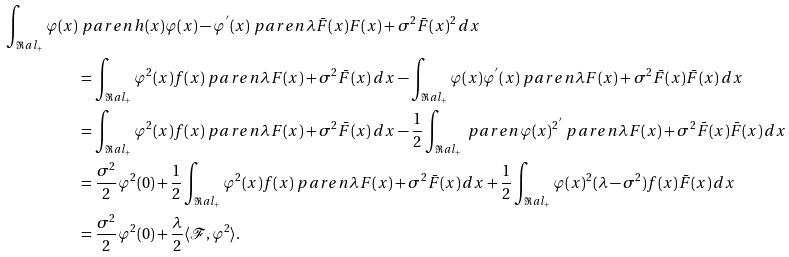<formula> <loc_0><loc_0><loc_500><loc_500>\int _ { \Re a l _ { + } } \varphi ( x ) & \ p a r e n { h ( x ) \varphi ( x ) - \varphi ^ { ^ { \prime } } ( x ) } \ p a r e n { \lambda \bar { F } ( x ) F ( x ) + \sigma ^ { 2 } \bar { F } ( x ) ^ { 2 } } \, d x \\ & = \int _ { \Re a l _ { + } } \varphi ^ { 2 } ( x ) f ( x ) \ p a r e n { \lambda F ( x ) + \sigma ^ { 2 } \bar { F } ( x ) } \, d x - \int _ { \Re a l _ { + } } \varphi ( x ) \varphi ^ { ^ { \prime } } ( x ) \ p a r e n { \lambda F ( x ) + \sigma ^ { 2 } \bar { F } ( x ) } \bar { F } ( x ) \, d x \\ & = \int _ { \Re a l _ { + } } \varphi ^ { 2 } ( x ) f ( x ) \ p a r e n { \lambda F ( x ) + \sigma ^ { 2 } \bar { F } ( x ) } \, d x - \frac { 1 } { 2 } \int _ { \Re a l _ { + } } \ p a r e n { \varphi ( x ) ^ { 2 } } ^ { ^ { \prime } } \ p a r e n { \lambda F ( x ) + \sigma ^ { 2 } \bar { F } ( x ) } \bar { F } ( x ) \, d x \\ & = \frac { \sigma ^ { 2 } } { 2 } \varphi ^ { 2 } ( 0 ) + \frac { 1 } { 2 } \int _ { \Re a l _ { + } } \varphi ^ { 2 } ( x ) f ( x ) \ p a r e n { \lambda F ( x ) + \sigma ^ { 2 } \bar { F } ( x ) } \, d x + \frac { 1 } { 2 } \int _ { \Re a l _ { + } } \varphi ( x ) ^ { 2 } ( \lambda - \sigma ^ { 2 } ) f ( x ) \bar { F } ( x ) \, d x \\ & = \frac { \sigma ^ { 2 } } { 2 } \varphi ^ { 2 } ( 0 ) + \frac { \lambda } { 2 } \langle \mathcal { F } , \varphi ^ { 2 } \rangle .</formula> 